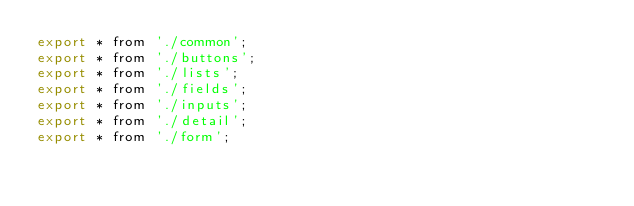Convert code to text. <code><loc_0><loc_0><loc_500><loc_500><_JavaScript_>export * from './common';
export * from './buttons';
export * from './lists';
export * from './fields';
export * from './inputs';
export * from './detail';
export * from './form';</code> 